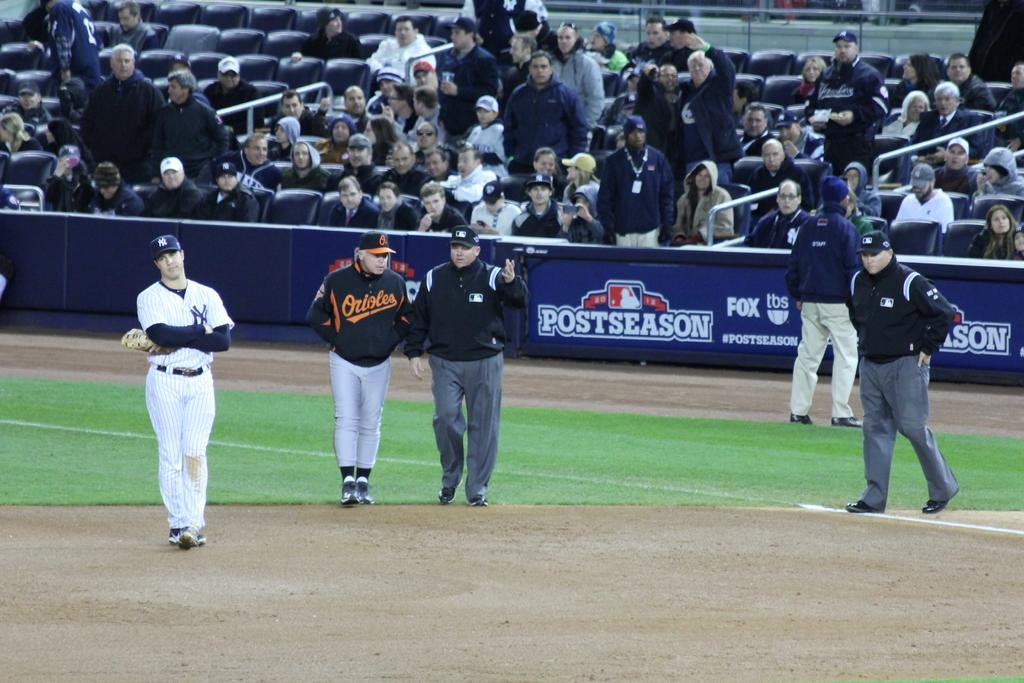<image>
Present a compact description of the photo's key features. A baseball field with Orioles and Yankees players and umpires. 